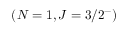Convert formula to latex. <formula><loc_0><loc_0><loc_500><loc_500>( N = 1 , J = 3 / 2 ^ { - } )</formula> 